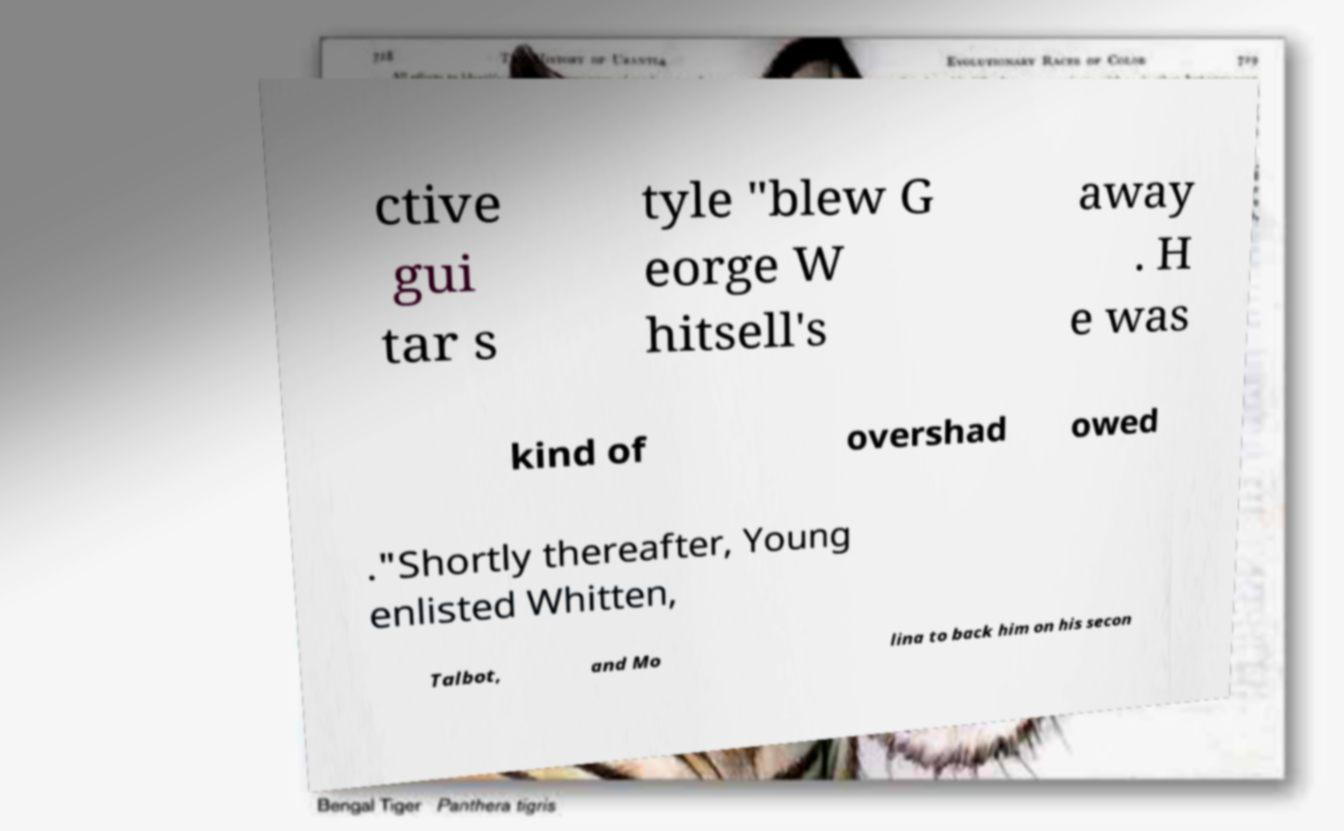Can you accurately transcribe the text from the provided image for me? ctive gui tar s tyle "blew G eorge W hitsell's away . H e was kind of overshad owed ."Shortly thereafter, Young enlisted Whitten, Talbot, and Mo lina to back him on his secon 